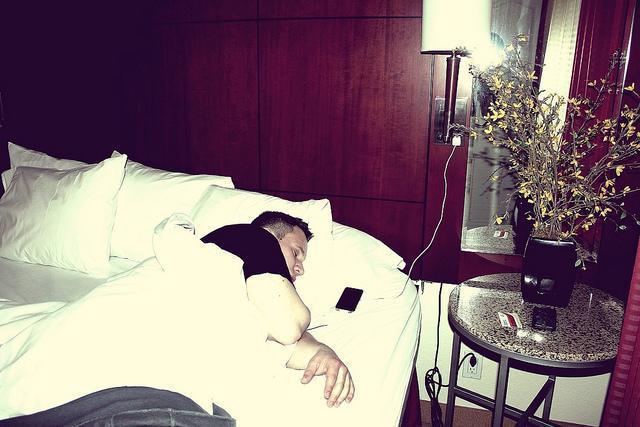How many vases are there?
Give a very brief answer. 1. How many scissors are to the left of the yarn?
Give a very brief answer. 0. 